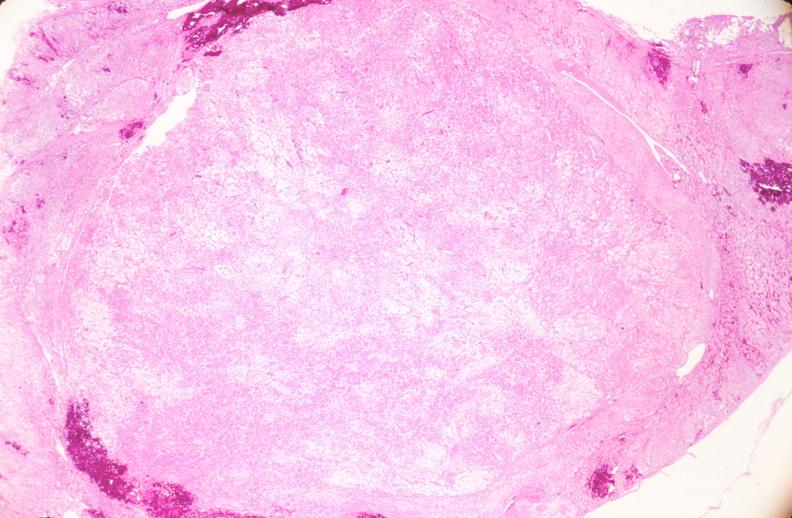does cystadenocarcinoma malignancy show uterus, leiomyoma?
Answer the question using a single word or phrase. No 